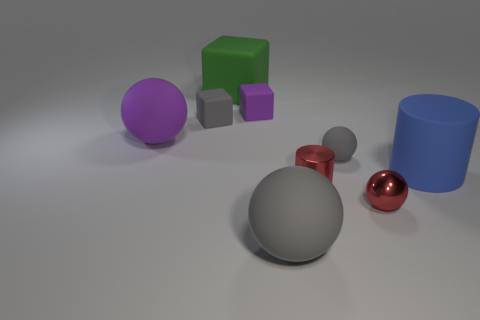Are there any reflections visible on the objects, and what can they tell us about the environment? The red and the tiny gray sphere show reflections that suggest a soft, diffused light source in the environment. However, we cannot determine specific details of the environment outside this frame since the reflections are not crisp enough to depict it accurately. The reflective quality does contribute to the perception of the objects' material properties, such as glossiness and texture. 